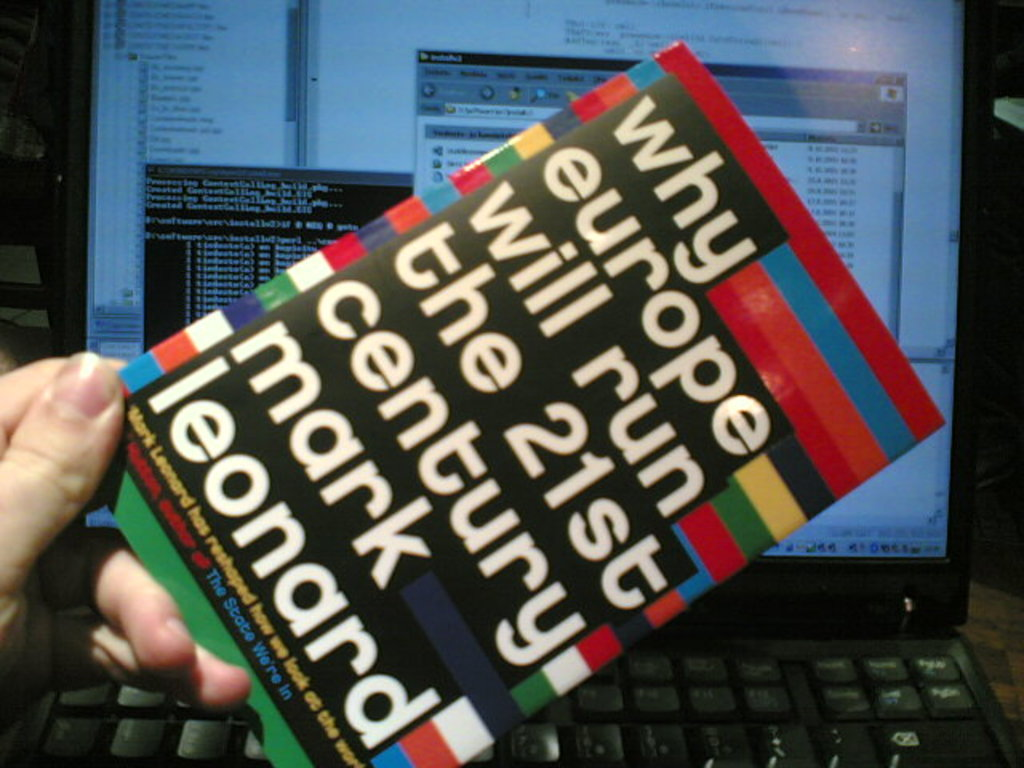Provide a one-sentence caption for the provided image. A person's hand is holding a copy of 'Why Europe Will Run the 21st Century' by Mark Leonard in front of a computer screen, highlighting a perspective on Europe's future influence. 